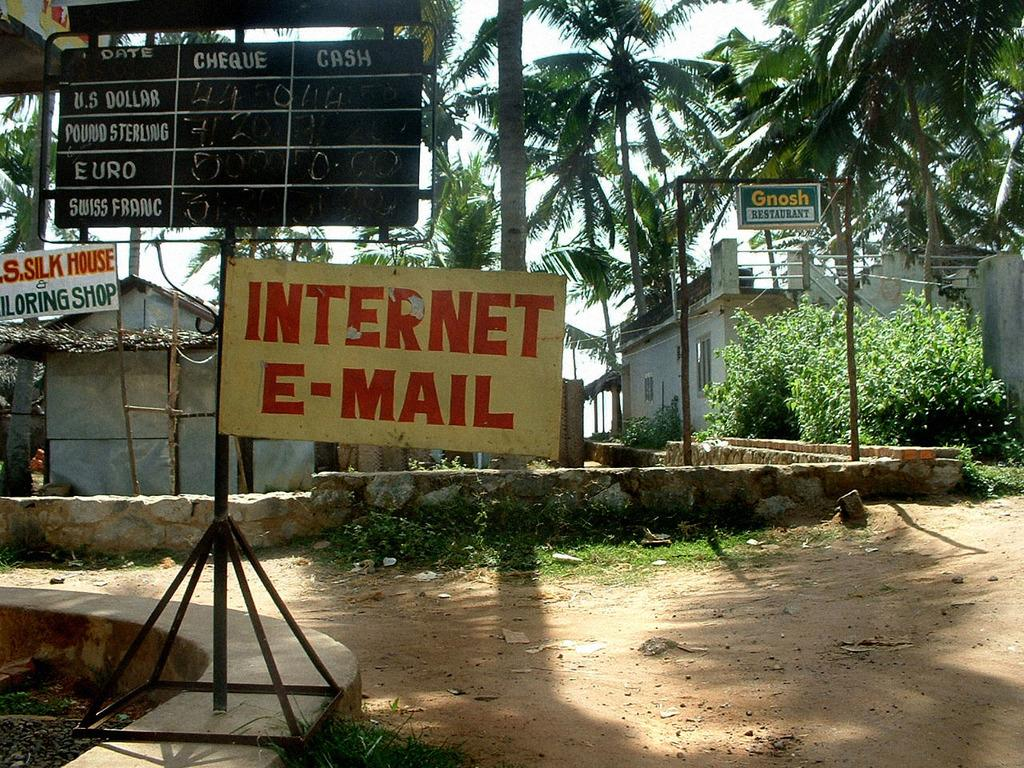What type of surface is visible in the image? There is a muddy surface in the image. What objects are near the muddy surface? There are boards near the muddy surface. What type of natural elements can be seen in the image? There are trees and plants in the image. What type of man-made structures are present in the image? There are houses in the image. What part of the sky is visible in the image? The sky is partially visible in the image. What type of pen is being used to write on the muddy surface in the image? There is no pen or writing activity visible in the image; it features a muddy surface with boards and natural elements. 